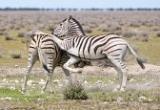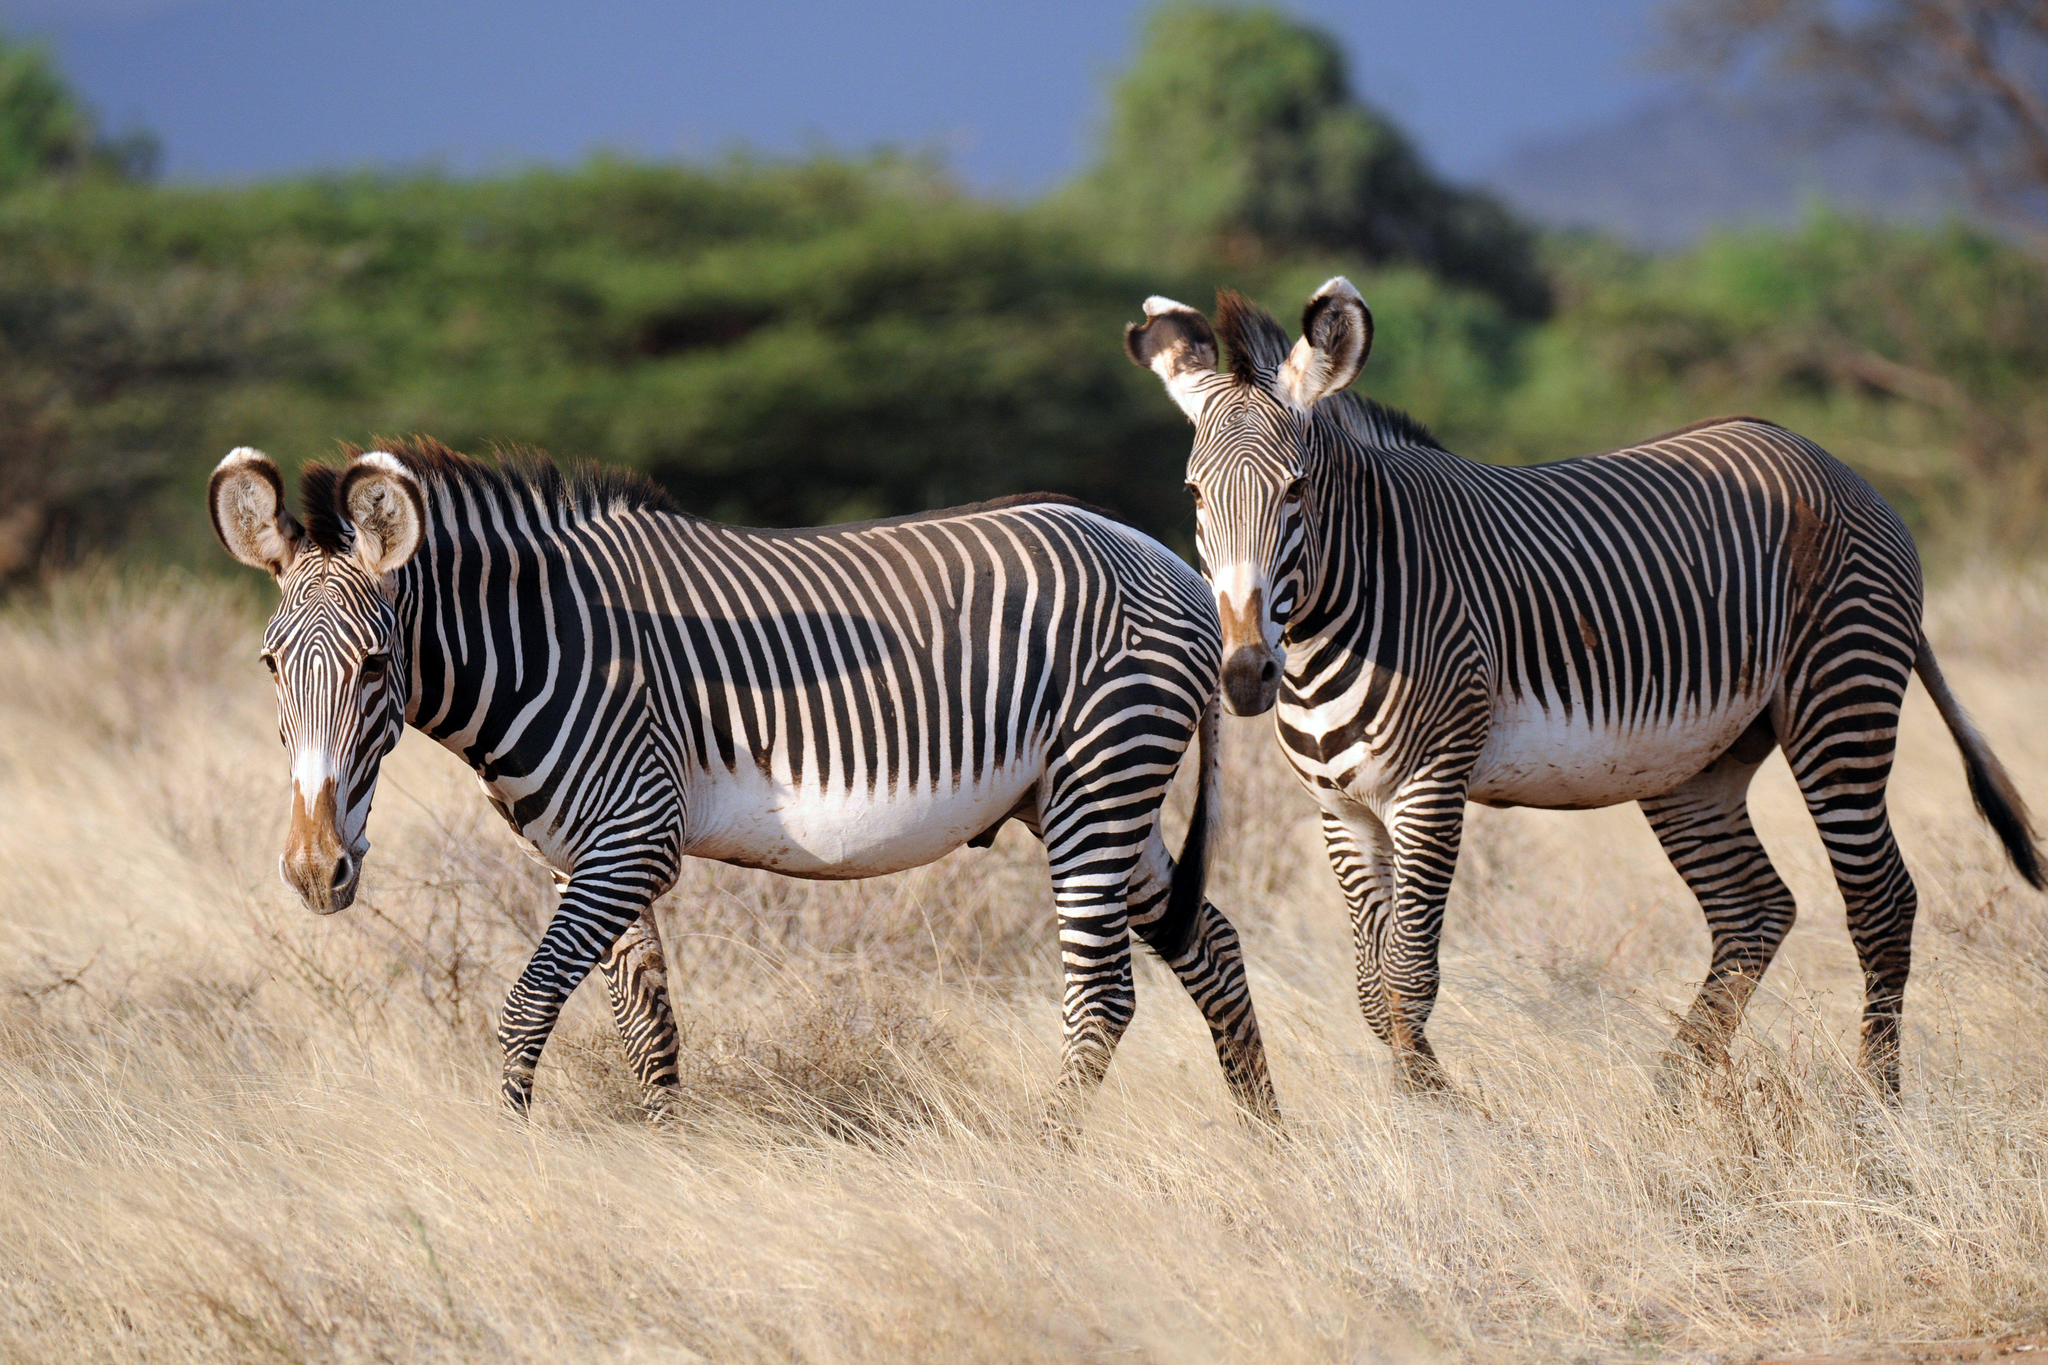The first image is the image on the left, the second image is the image on the right. For the images displayed, is the sentence "The image on the right shows two zebras embracing each other with their heads." factually correct? Answer yes or no. No. The first image is the image on the left, the second image is the image on the right. Assess this claim about the two images: "One image shows two zebra standing in profile turned toward one another, each one with its head over the back of the other.". Correct or not? Answer yes or no. No. 